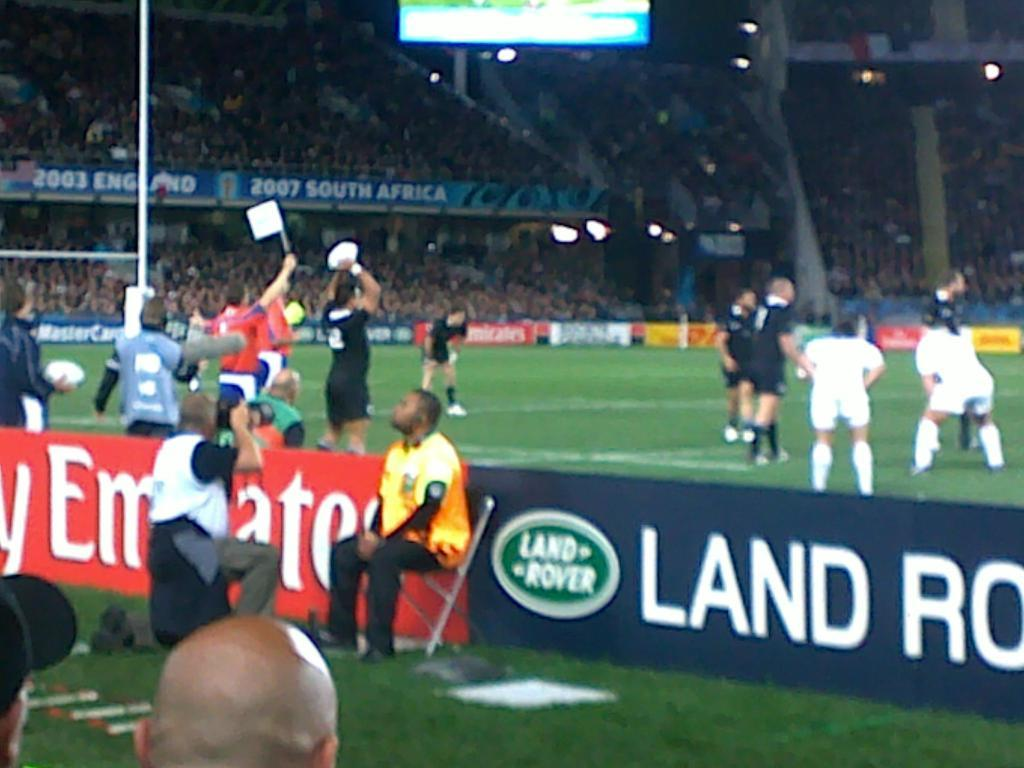<image>
Write a terse but informative summary of the picture. The soccer players are on the field behind the sign for Land Rover. 